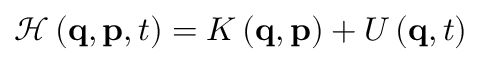Convert formula to latex. <formula><loc_0><loc_0><loc_500><loc_500>\mathcal { H } \left ( q , p , t \right ) = K \left ( q , p \right ) + U \left ( q , t \right )</formula> 